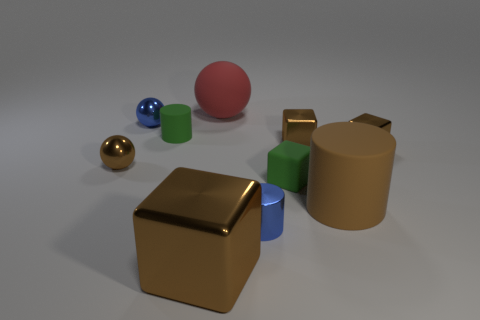Subtract all rubber cylinders. How many cylinders are left? 1 Subtract all blue spheres. How many spheres are left? 2 Subtract all spheres. How many objects are left? 7 Subtract all brown cylinders. How many yellow spheres are left? 0 Subtract all tiny matte cubes. Subtract all red matte things. How many objects are left? 8 Add 4 shiny blocks. How many shiny blocks are left? 7 Add 4 small blue shiny objects. How many small blue shiny objects exist? 6 Subtract 0 gray cubes. How many objects are left? 10 Subtract 2 cubes. How many cubes are left? 2 Subtract all yellow blocks. Subtract all blue cylinders. How many blocks are left? 4 